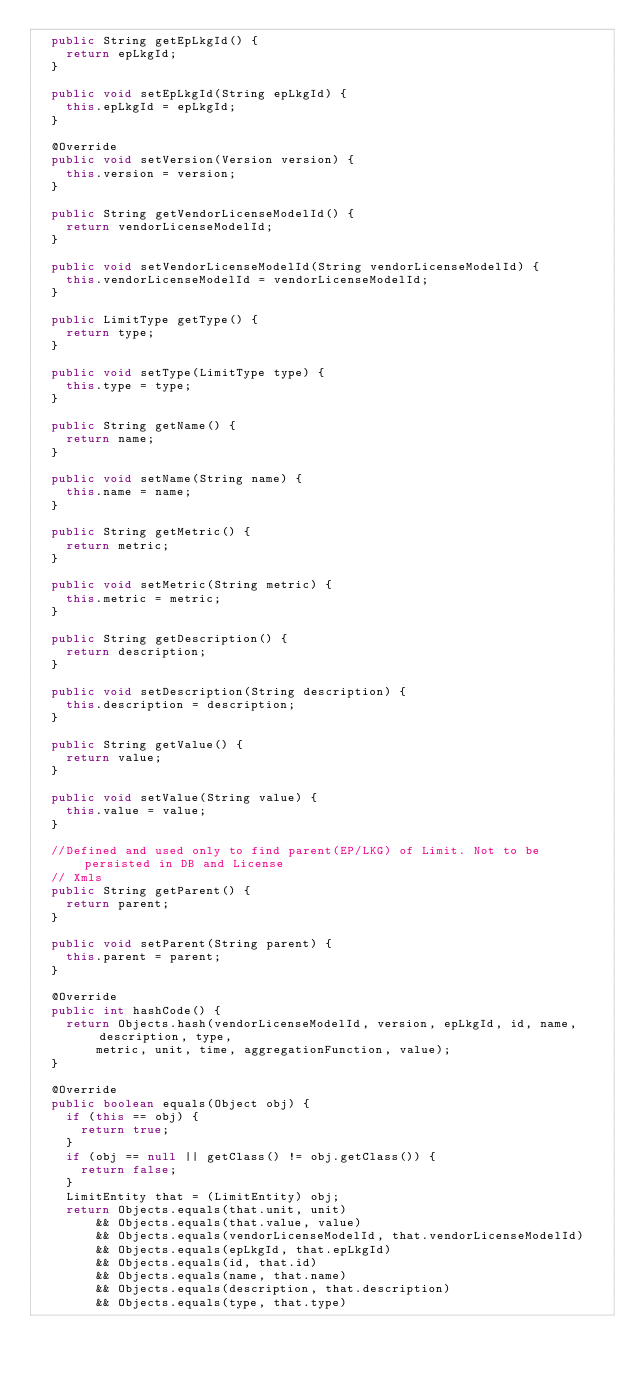<code> <loc_0><loc_0><loc_500><loc_500><_Java_>  public String getEpLkgId() {
    return epLkgId;
  }

  public void setEpLkgId(String epLkgId) {
    this.epLkgId = epLkgId;
  }

  @Override
  public void setVersion(Version version) {
    this.version = version;
  }

  public String getVendorLicenseModelId() {
    return vendorLicenseModelId;
  }

  public void setVendorLicenseModelId(String vendorLicenseModelId) {
    this.vendorLicenseModelId = vendorLicenseModelId;
  }

  public LimitType getType() {
    return type;
  }

  public void setType(LimitType type) {
    this.type = type;
  }

  public String getName() {
    return name;
  }

  public void setName(String name) {
    this.name = name;
  }

  public String getMetric() {
    return metric;
  }

  public void setMetric(String metric) {
    this.metric = metric;
  }

  public String getDescription() {
    return description;
  }

  public void setDescription(String description) {
    this.description = description;
  }

  public String getValue() {
    return value;
  }

  public void setValue(String value) {
    this.value = value;
  }

  //Defined and used only to find parent(EP/LKG) of Limit. Not to be persisted in DB and License
  // Xmls
  public String getParent() {
    return parent;
  }

  public void setParent(String parent) {
    this.parent = parent;
  }

  @Override
  public int hashCode() {
    return Objects.hash(vendorLicenseModelId, version, epLkgId, id, name, description, type,
        metric, unit, time, aggregationFunction, value);
  }

  @Override
  public boolean equals(Object obj) {
    if (this == obj) {
      return true;
    }
    if (obj == null || getClass() != obj.getClass()) {
      return false;
    }
    LimitEntity that = (LimitEntity) obj;
    return Objects.equals(that.unit, unit)
        && Objects.equals(that.value, value)
        && Objects.equals(vendorLicenseModelId, that.vendorLicenseModelId)
        && Objects.equals(epLkgId, that.epLkgId)
        && Objects.equals(id, that.id)
        && Objects.equals(name, that.name)
        && Objects.equals(description, that.description)
        && Objects.equals(type, that.type)</code> 